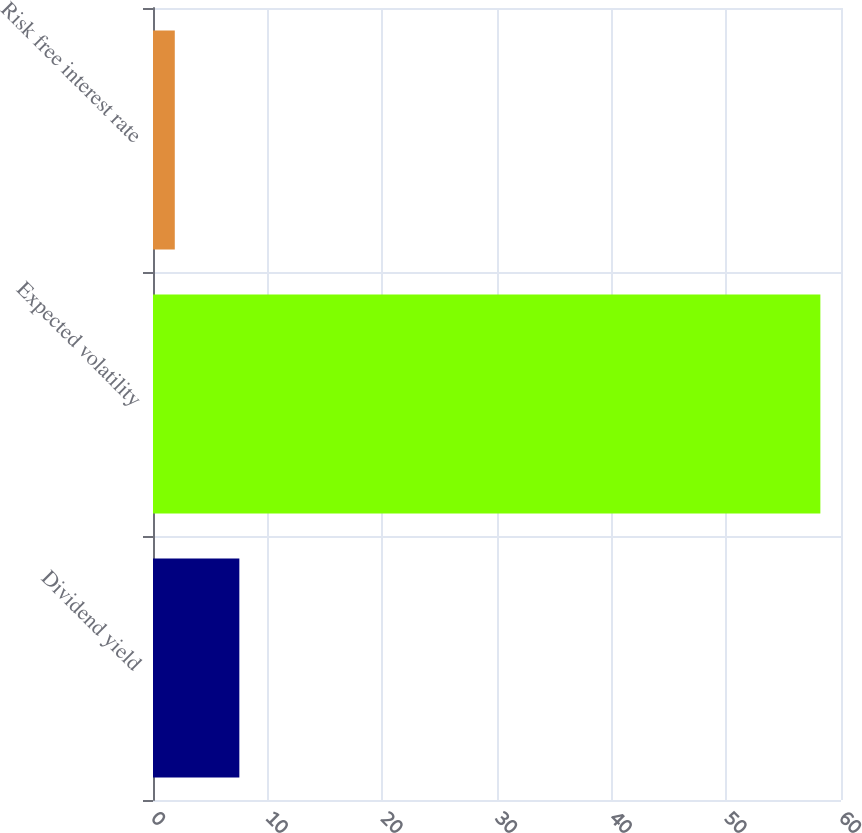Convert chart to OTSL. <chart><loc_0><loc_0><loc_500><loc_500><bar_chart><fcel>Dividend yield<fcel>Expected volatility<fcel>Risk free interest rate<nl><fcel>7.53<fcel>58.2<fcel>1.9<nl></chart> 